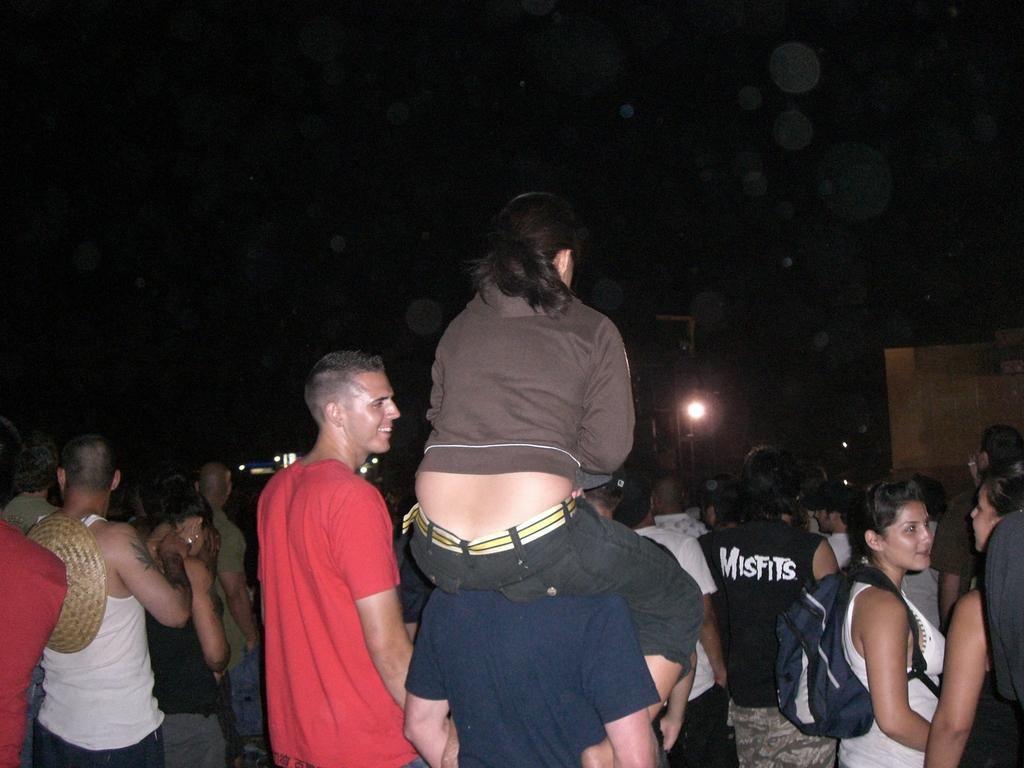What is the woman doing in the image? The woman is sitting on a person's neck in the image. What can be seen in the background of the image? There is a group of persons standing on the road and a light visible in the background of the image. What type of measuring device is being used by the woman in the image? There is no measuring device visible in the image. How many clocks can be seen in the image? There are no clocks present in the image. 